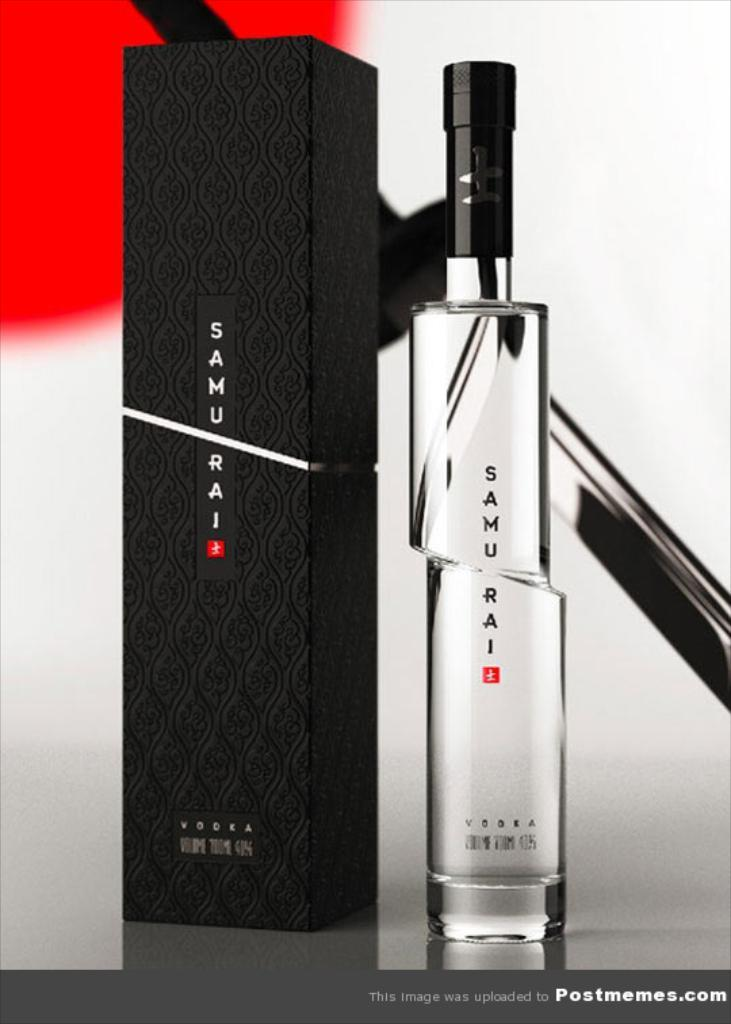What object can be seen in the image that might contain a liquid? There is a bottle in the image that might contain a liquid. What other object can be seen in the image that is typically used for storage? There is a box in the image that is typically used for storage. What can be seen on the wall in the image? There is a wall with a design in the image. What type of object in the image contains text? There is a poster with text in the image. Can you see any toes in the image? There are no toes visible in the image. What is the argument about in the image? There is no argument present in the image. 